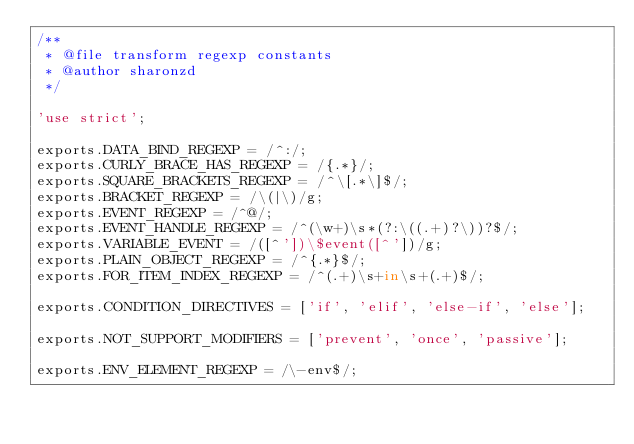<code> <loc_0><loc_0><loc_500><loc_500><_JavaScript_>/**
 * @file transform regexp constants
 * @author sharonzd
 */

'use strict';

exports.DATA_BIND_REGEXP = /^:/;
exports.CURLY_BRACE_HAS_REGEXP = /{.*}/;
exports.SQUARE_BRACKETS_REGEXP = /^\[.*\]$/;
exports.BRACKET_REGEXP = /\(|\)/g;
exports.EVENT_REGEXP = /^@/;
exports.EVENT_HANDLE_REGEXP = /^(\w+)\s*(?:\((.+)?\))?$/;
exports.VARIABLE_EVENT = /([^'])\$event([^'])/g;
exports.PLAIN_OBJECT_REGEXP = /^{.*}$/;
exports.FOR_ITEM_INDEX_REGEXP = /^(.+)\s+in\s+(.+)$/;

exports.CONDITION_DIRECTIVES = ['if', 'elif', 'else-if', 'else'];

exports.NOT_SUPPORT_MODIFIERS = ['prevent', 'once', 'passive'];

exports.ENV_ELEMENT_REGEXP = /\-env$/;
</code> 